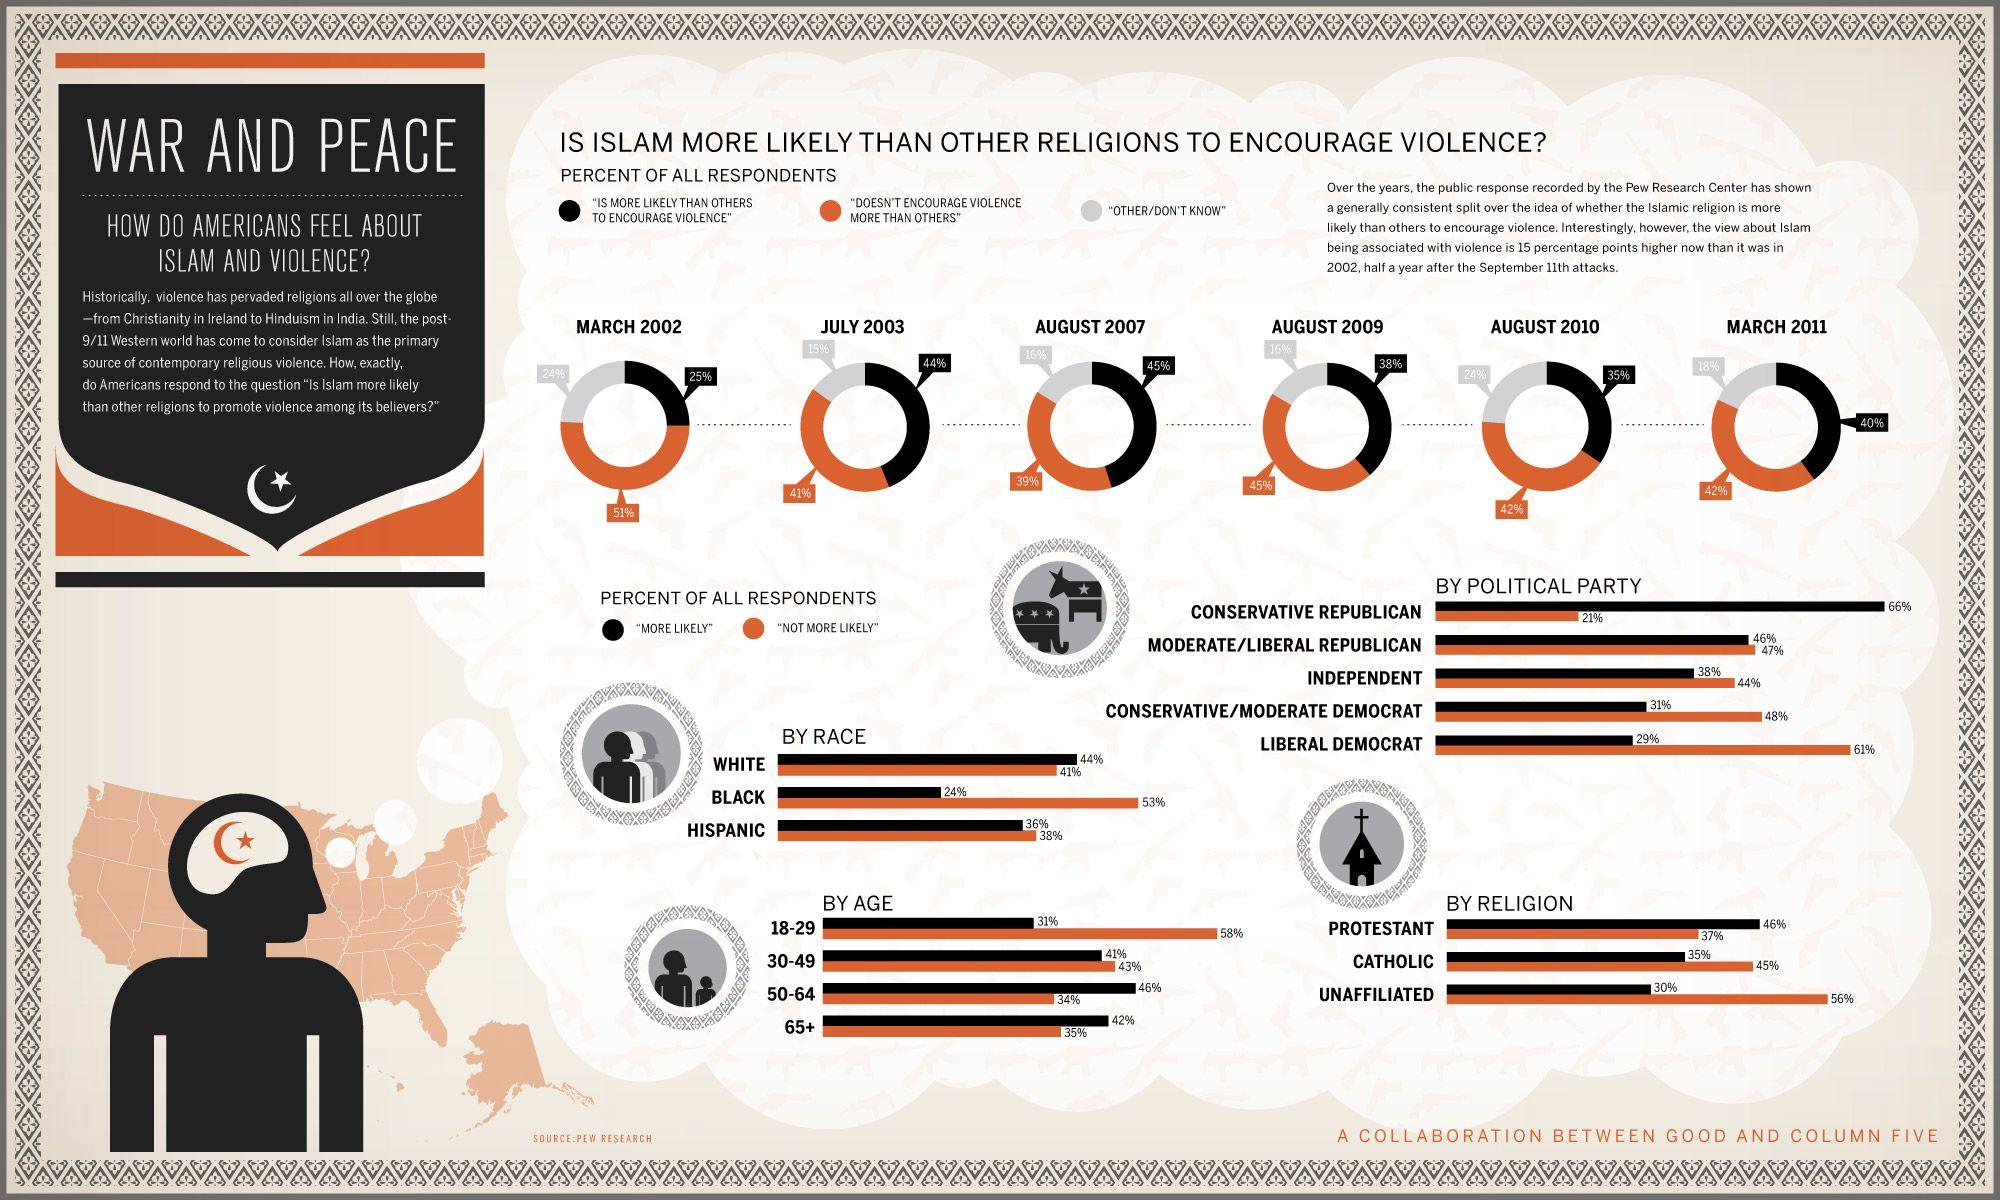Point out several critical features in this image. According to a survey conducted in August 2009, 45% of people responded that Islam does not encourage violence more than other religions. According to the March 2011 survey, 42% of respondents stated that Islam does not encourage violence more than other religions. According to the data, 46% of liberal/moderate Republicans responded "more likely" to the question. According to a survey conducted in August 2010, 35% of people responded that Islam is more likely than others to encourage violence. According to a survey conducted in March 2002, 25% of people responded that Islam is more likely than others to encourage violence. 